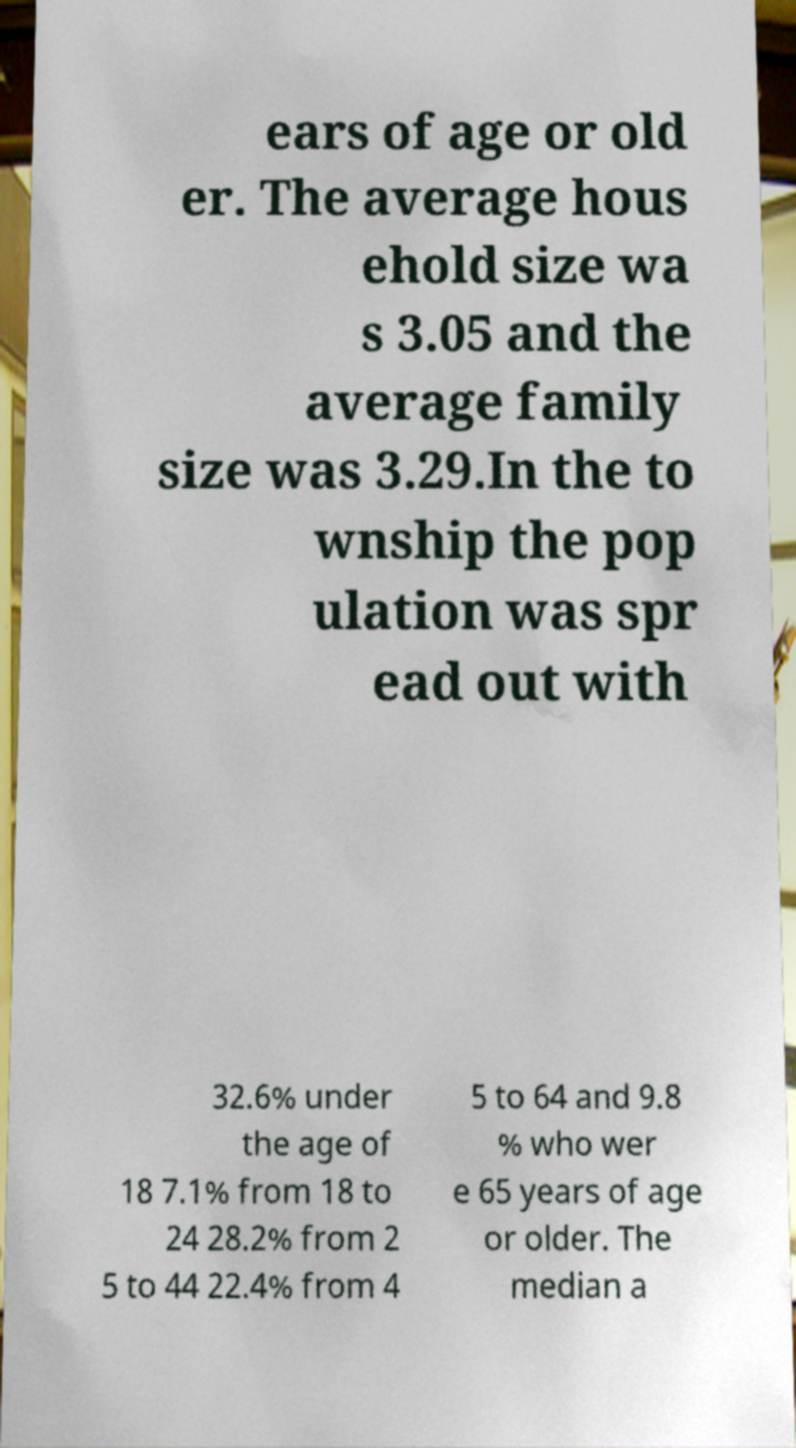Can you accurately transcribe the text from the provided image for me? ears of age or old er. The average hous ehold size wa s 3.05 and the average family size was 3.29.In the to wnship the pop ulation was spr ead out with 32.6% under the age of 18 7.1% from 18 to 24 28.2% from 2 5 to 44 22.4% from 4 5 to 64 and 9.8 % who wer e 65 years of age or older. The median a 